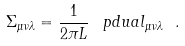<formula> <loc_0><loc_0><loc_500><loc_500>\Sigma _ { \mu \nu \lambda } = \frac { 1 } { 2 \pi L } \, \ p d u a l _ { \mu \nu \lambda } \ .</formula> 